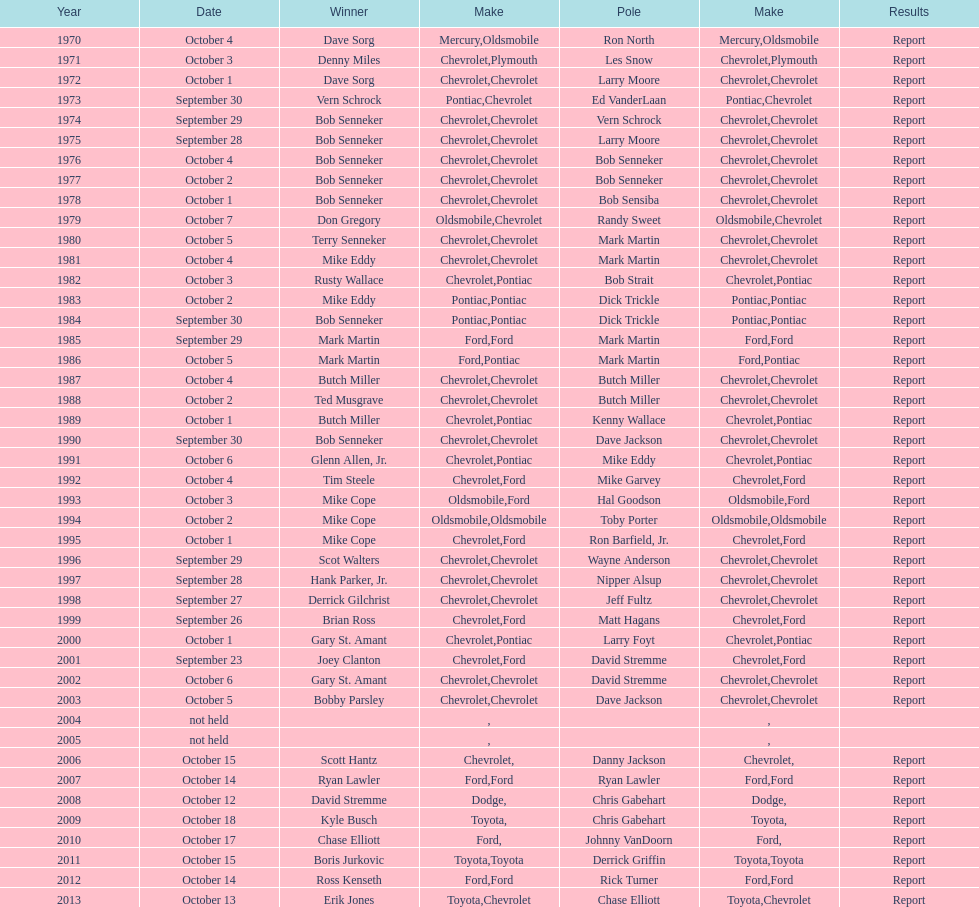Which month held the most winchester 400 races? October. 